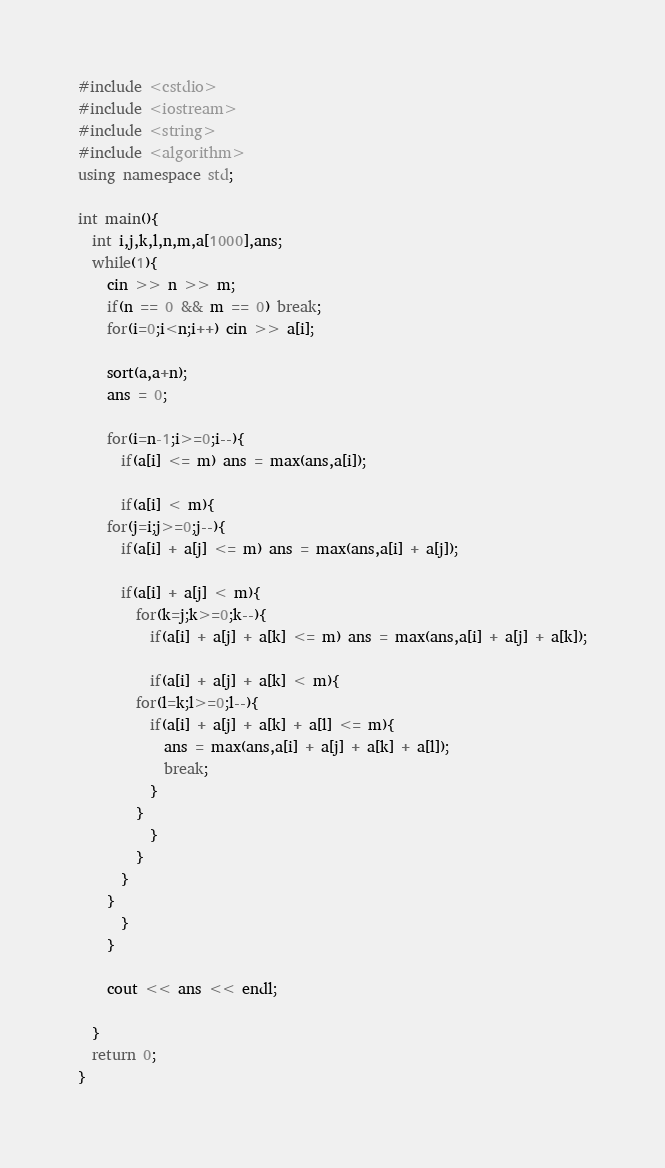Convert code to text. <code><loc_0><loc_0><loc_500><loc_500><_C++_>#include <cstdio>
#include <iostream>
#include <string>
#include <algorithm>
using namespace std;

int main(){
  int i,j,k,l,n,m,a[1000],ans;
  while(1){
    cin >> n >> m;
    if(n == 0 && m == 0) break;
    for(i=0;i<n;i++) cin >> a[i];

    sort(a,a+n);
    ans = 0;

    for(i=n-1;i>=0;i--){
      if(a[i] <= m) ans = max(ans,a[i]);

      if(a[i] < m){
	for(j=i;j>=0;j--){
	  if(a[i] + a[j] <= m) ans = max(ans,a[i] + a[j]);
	  
	  if(a[i] + a[j] < m){
	    for(k=j;k>=0;k--){
	      if(a[i] + a[j] + a[k] <= m) ans = max(ans,a[i] + a[j] + a[k]);
	      
	      if(a[i] + a[j] + a[k] < m){
		for(l=k;l>=0;l--){
		  if(a[i] + a[j] + a[k] + a[l] <= m){
		    ans = max(ans,a[i] + a[j] + a[k] + a[l]);
		    break;
		  }
		}
	      }
	    }
	  }
	}
      }
    }

    cout << ans << endl;

  }
  return 0;
}</code> 